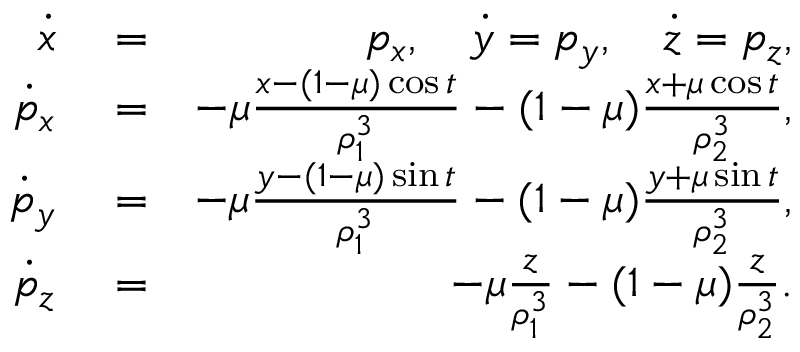<formula> <loc_0><loc_0><loc_500><loc_500>\begin{array} { r l r } { \dot { x } } & = } & { p _ { x } , \quad \dot { y } = p _ { y } , \quad \dot { z } = p _ { z } , } \\ { \dot { p } _ { x } } & = } & { - \mu \frac { x - ( 1 - \mu ) \cos { t } } { \rho _ { 1 } ^ { 3 } } - ( 1 - \mu ) \frac { x + \mu \cos { t } } { \rho _ { 2 } ^ { 3 } } , } \\ { \dot { p } _ { y } } & = } & { - \mu \frac { y - ( 1 - \mu ) \sin { t } } { \rho _ { 1 } ^ { 3 } } - ( 1 - \mu ) \frac { y + \mu \sin { t } } { \rho _ { 2 } ^ { 3 } } , } \\ { \dot { p } _ { z } } & = } & { - \mu \frac { z } { \rho _ { 1 } ^ { 3 } } - ( 1 - \mu ) \frac { z } { \rho _ { 2 } ^ { 3 } } . } \end{array}</formula> 